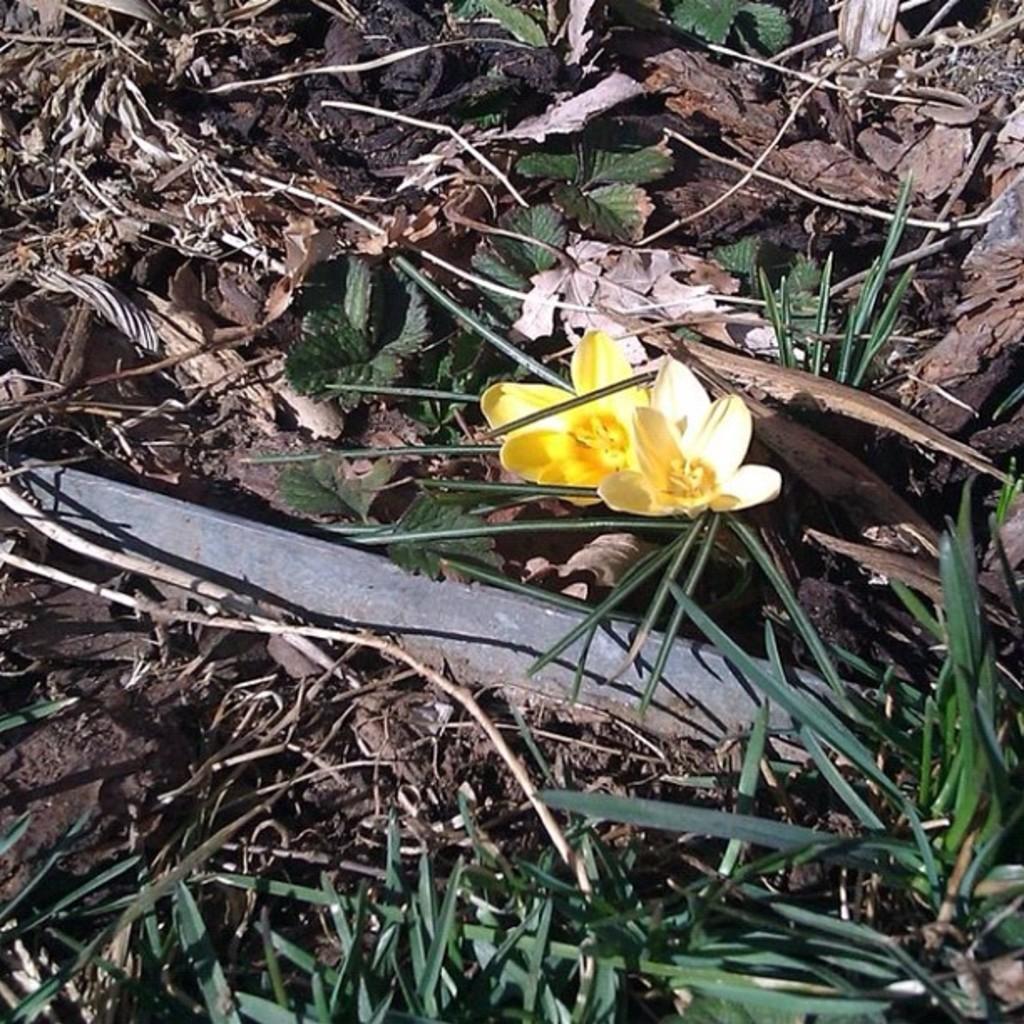Please provide a concise description of this image. In this image there are two flowers on the ground. At the bottom there are plants. Beside the flowers there are leaves. On the ground there is sand. 